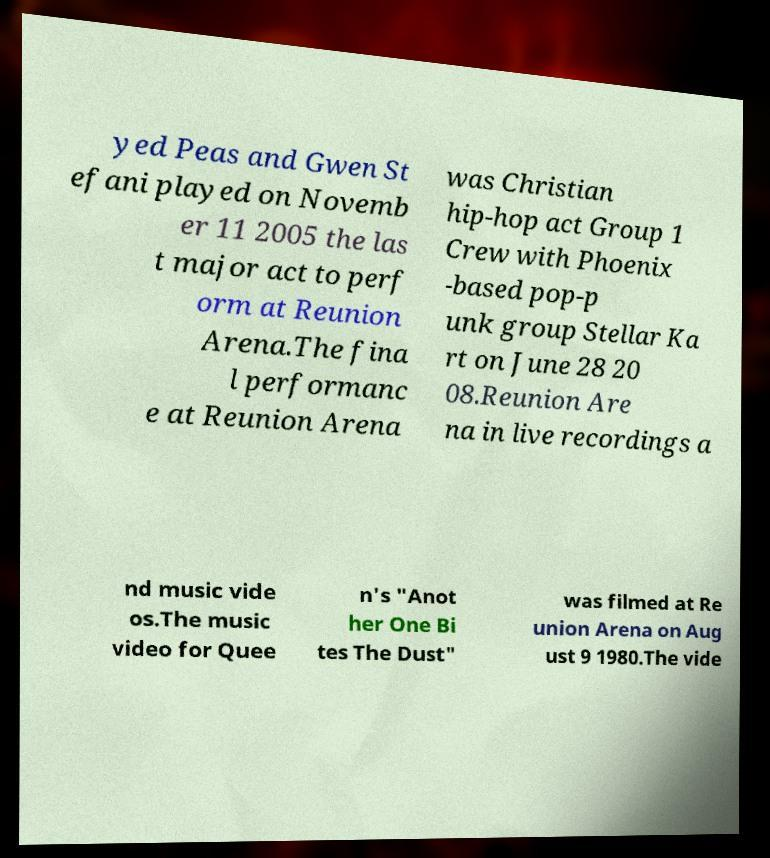There's text embedded in this image that I need extracted. Can you transcribe it verbatim? yed Peas and Gwen St efani played on Novemb er 11 2005 the las t major act to perf orm at Reunion Arena.The fina l performanc e at Reunion Arena was Christian hip-hop act Group 1 Crew with Phoenix -based pop-p unk group Stellar Ka rt on June 28 20 08.Reunion Are na in live recordings a nd music vide os.The music video for Quee n's "Anot her One Bi tes The Dust" was filmed at Re union Arena on Aug ust 9 1980.The vide 